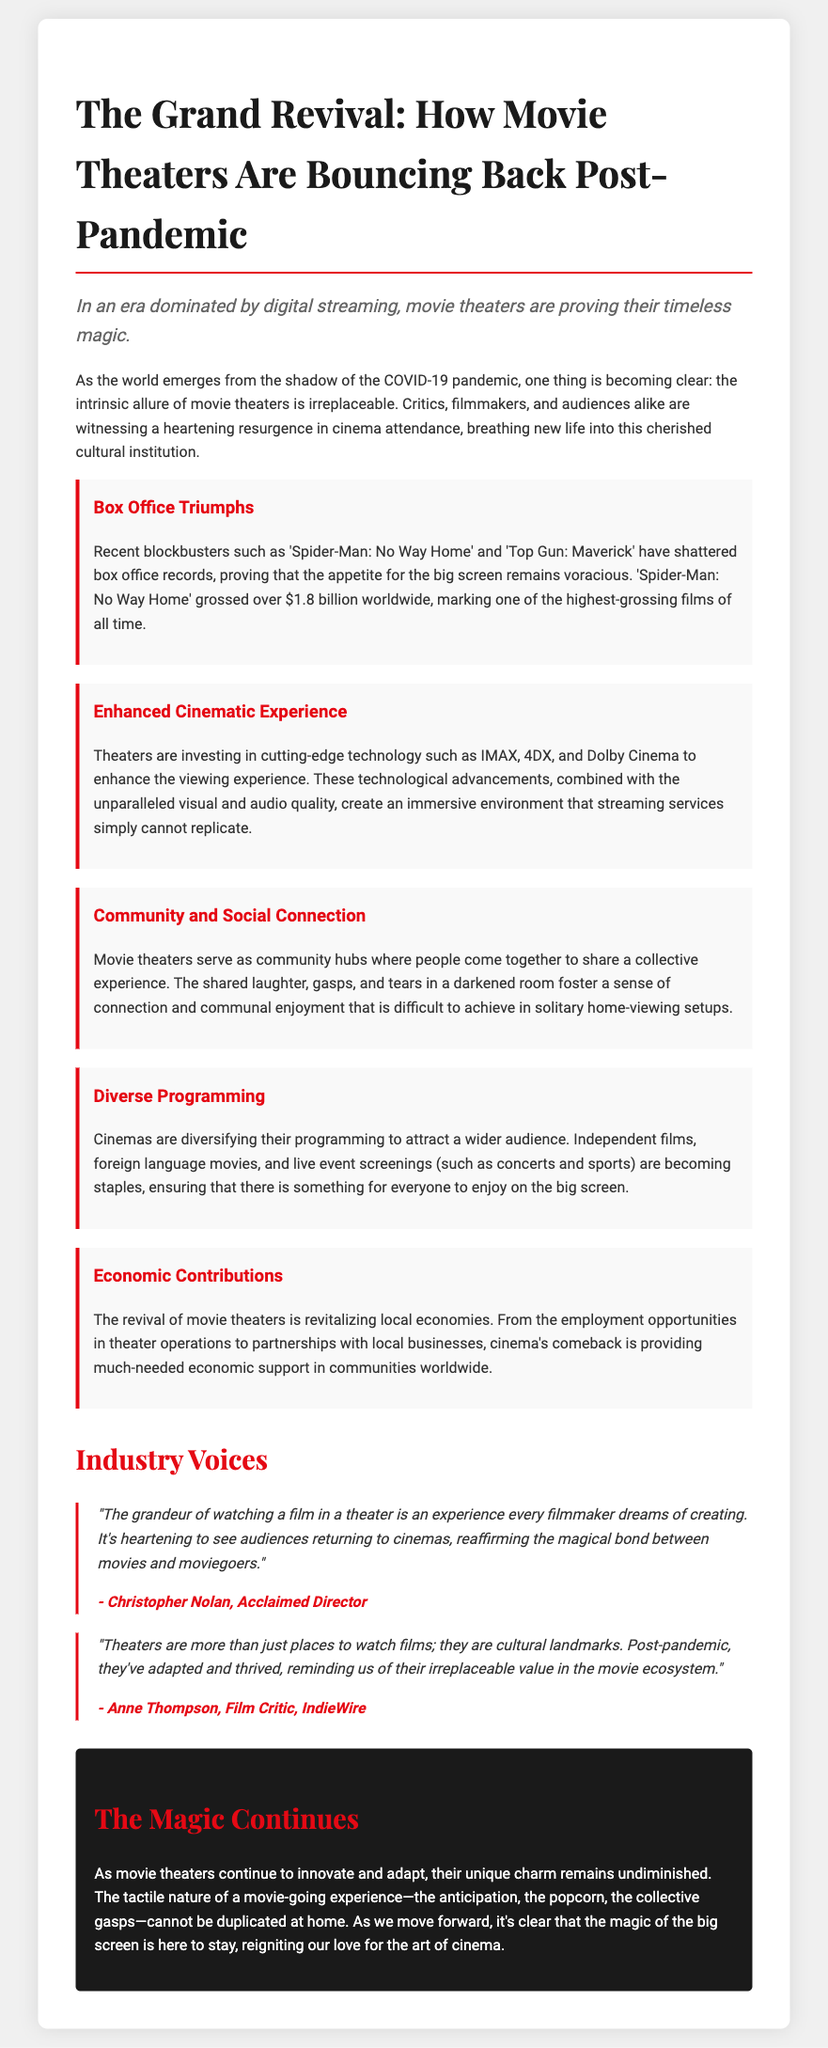What recent blockbuster grossed over $1.8 billion? The document mentions 'Spider-Man: No Way Home' as the blockbuster that grossed over $1.8 billion.
Answer: 'Spider-Man: No Way Home' Which technology is enhancing the cinematic experience? The document lists technologies like IMAX, 4DX, and Dolby Cinema as enhancements to the viewing experience.
Answer: IMAX, 4DX, and Dolby Cinema Who is the acclaimed director quoted in the document? The quote in the document is attributed to Christopher Nolan, who is described as an acclaimed director.
Answer: Christopher Nolan What is one way theaters are diversifying programming? The document mentions independent films as one method of diversifying their offerings.
Answer: Independent films According to the document, what do movie theaters serve as? The document states that movie theaters serve as community hubs, emphasizing their social role.
Answer: Community hubs What is a major benefit of the revival of movie theaters mentioned? The document highlights that the revival is revitalizing local economies as a major benefit.
Answer: Revitalizing local economies What does the conclusion of the document assert? The conclusion emphasizes that the magic of the movie-going experience cannot be duplicated at home.
Answer: Cannot be duplicated at home Which acclaimed film critic is quoted in the document? The document cites Anne Thompson as the film critic providing a quote.
Answer: Anne Thompson 